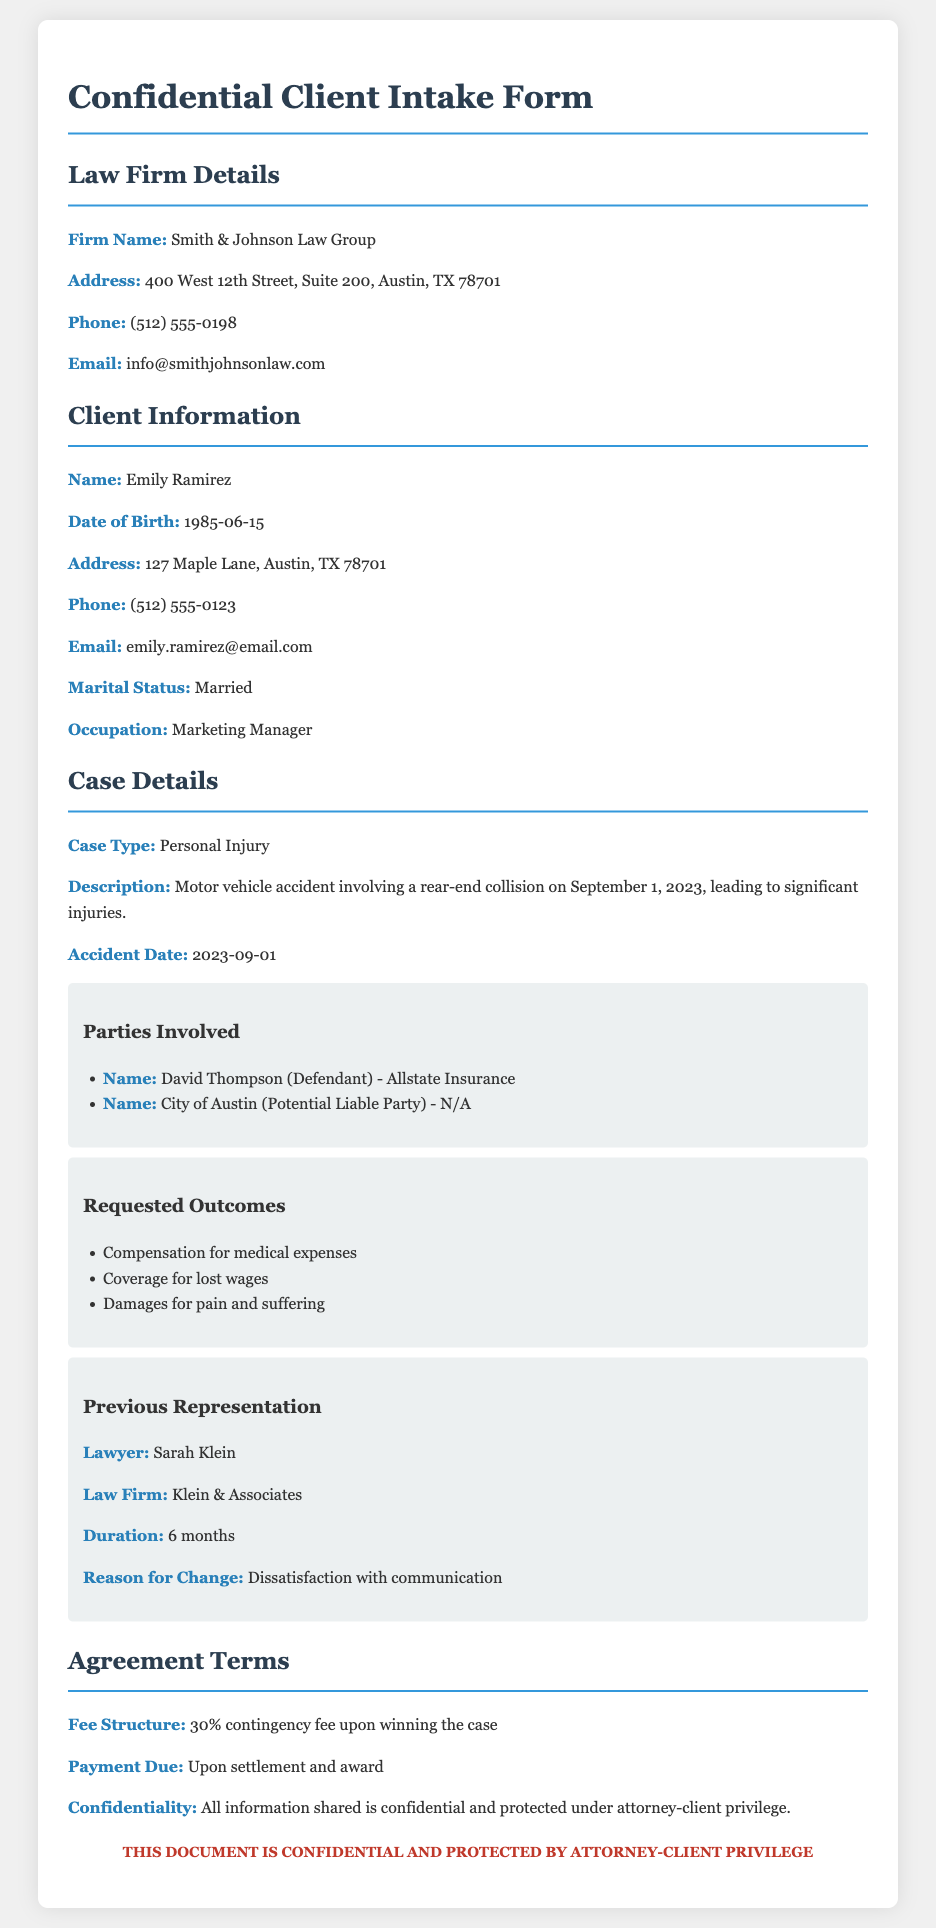What is the name of the law firm? The law firm is identified in the document under "Firm Name."
Answer: Smith & Johnson Law Group Who is the client? The document specifies the client's name in the "Client Information" section.
Answer: Emily Ramirez What is the accident date? The date of the motor vehicle accident is listed in the "Case Details" section.
Answer: 2023-09-01 What is the fee structure? The fee structure is detailed in the "Agreement Terms" section.
Answer: 30% contingency fee upon winning the case What is the reason for the client changing lawyers? The reason is provided in the "Previous Representation" sub-section under "Reason for Change."
Answer: Dissatisfaction with communication How many parties are involved in the case? The number of parties involved can be determined from the "Parties Involved" subsection.
Answer: 2 What type of case is this? The document describes the case type in the "Case Details" section.
Answer: Personal Injury What is the client's occupation? The client's occupation is mentioned in the "Client Information" section under "Occupation."
Answer: Marketing Manager What are the requested outcomes of the case? The requested outcomes can be found in the "Requested Outcomes" sub-section.
Answer: Compensation for medical expenses, Coverage for lost wages, Damages for pain and suffering 